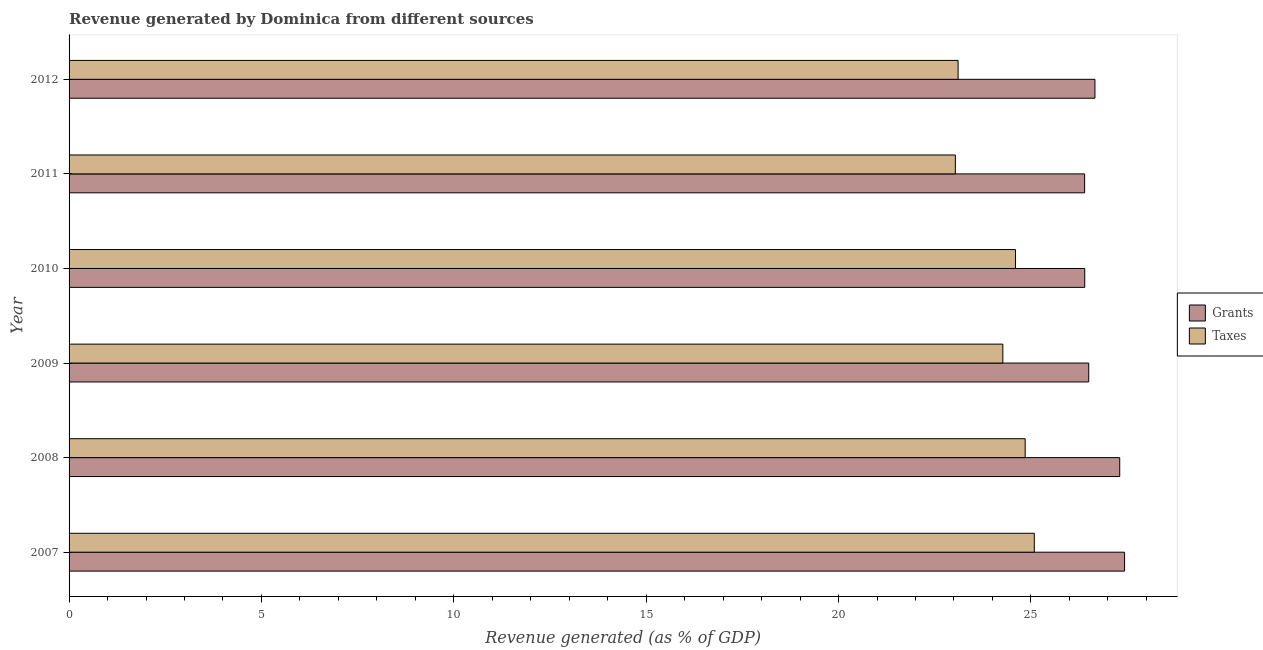How many different coloured bars are there?
Give a very brief answer. 2. How many groups of bars are there?
Make the answer very short. 6. Are the number of bars on each tick of the Y-axis equal?
Ensure brevity in your answer.  Yes. What is the revenue generated by taxes in 2007?
Provide a short and direct response. 25.09. Across all years, what is the maximum revenue generated by grants?
Your answer should be compact. 27.43. Across all years, what is the minimum revenue generated by taxes?
Ensure brevity in your answer.  23.04. In which year was the revenue generated by taxes maximum?
Ensure brevity in your answer.  2007. What is the total revenue generated by taxes in the graph?
Ensure brevity in your answer.  144.95. What is the difference between the revenue generated by taxes in 2007 and that in 2012?
Make the answer very short. 1.98. What is the difference between the revenue generated by grants in 2009 and the revenue generated by taxes in 2011?
Give a very brief answer. 3.47. What is the average revenue generated by taxes per year?
Keep it short and to the point. 24.16. In the year 2010, what is the difference between the revenue generated by grants and revenue generated by taxes?
Keep it short and to the point. 1.8. What is the ratio of the revenue generated by taxes in 2007 to that in 2009?
Offer a very short reply. 1.03. Is the revenue generated by grants in 2010 less than that in 2011?
Make the answer very short. No. What is the difference between the highest and the second highest revenue generated by grants?
Your answer should be compact. 0.13. What is the difference between the highest and the lowest revenue generated by taxes?
Make the answer very short. 2.05. Is the sum of the revenue generated by taxes in 2007 and 2011 greater than the maximum revenue generated by grants across all years?
Keep it short and to the point. Yes. What does the 2nd bar from the top in 2007 represents?
Offer a terse response. Grants. What does the 1st bar from the bottom in 2011 represents?
Ensure brevity in your answer.  Grants. How many bars are there?
Your answer should be compact. 12. What is the difference between two consecutive major ticks on the X-axis?
Make the answer very short. 5. Are the values on the major ticks of X-axis written in scientific E-notation?
Your answer should be very brief. No. How many legend labels are there?
Ensure brevity in your answer.  2. How are the legend labels stacked?
Keep it short and to the point. Vertical. What is the title of the graph?
Your answer should be very brief. Revenue generated by Dominica from different sources. Does "Nonresident" appear as one of the legend labels in the graph?
Offer a very short reply. No. What is the label or title of the X-axis?
Offer a very short reply. Revenue generated (as % of GDP). What is the label or title of the Y-axis?
Ensure brevity in your answer.  Year. What is the Revenue generated (as % of GDP) in Grants in 2007?
Your answer should be very brief. 27.43. What is the Revenue generated (as % of GDP) in Taxes in 2007?
Give a very brief answer. 25.09. What is the Revenue generated (as % of GDP) in Grants in 2008?
Offer a very short reply. 27.31. What is the Revenue generated (as % of GDP) of Taxes in 2008?
Keep it short and to the point. 24.85. What is the Revenue generated (as % of GDP) in Grants in 2009?
Your answer should be very brief. 26.5. What is the Revenue generated (as % of GDP) of Taxes in 2009?
Make the answer very short. 24.27. What is the Revenue generated (as % of GDP) of Grants in 2010?
Offer a terse response. 26.4. What is the Revenue generated (as % of GDP) in Taxes in 2010?
Your answer should be compact. 24.6. What is the Revenue generated (as % of GDP) in Grants in 2011?
Provide a short and direct response. 26.4. What is the Revenue generated (as % of GDP) in Taxes in 2011?
Make the answer very short. 23.04. What is the Revenue generated (as % of GDP) in Grants in 2012?
Your response must be concise. 26.66. What is the Revenue generated (as % of GDP) in Taxes in 2012?
Your answer should be compact. 23.11. Across all years, what is the maximum Revenue generated (as % of GDP) of Grants?
Your answer should be very brief. 27.43. Across all years, what is the maximum Revenue generated (as % of GDP) of Taxes?
Make the answer very short. 25.09. Across all years, what is the minimum Revenue generated (as % of GDP) of Grants?
Your answer should be compact. 26.4. Across all years, what is the minimum Revenue generated (as % of GDP) in Taxes?
Provide a succinct answer. 23.04. What is the total Revenue generated (as % of GDP) in Grants in the graph?
Ensure brevity in your answer.  160.7. What is the total Revenue generated (as % of GDP) in Taxes in the graph?
Offer a very short reply. 144.95. What is the difference between the Revenue generated (as % of GDP) in Grants in 2007 and that in 2008?
Make the answer very short. 0.13. What is the difference between the Revenue generated (as % of GDP) of Taxes in 2007 and that in 2008?
Make the answer very short. 0.24. What is the difference between the Revenue generated (as % of GDP) in Grants in 2007 and that in 2009?
Keep it short and to the point. 0.93. What is the difference between the Revenue generated (as % of GDP) in Taxes in 2007 and that in 2009?
Give a very brief answer. 0.82. What is the difference between the Revenue generated (as % of GDP) in Grants in 2007 and that in 2010?
Keep it short and to the point. 1.03. What is the difference between the Revenue generated (as % of GDP) in Taxes in 2007 and that in 2010?
Your answer should be very brief. 0.49. What is the difference between the Revenue generated (as % of GDP) in Grants in 2007 and that in 2011?
Ensure brevity in your answer.  1.04. What is the difference between the Revenue generated (as % of GDP) of Taxes in 2007 and that in 2011?
Provide a short and direct response. 2.05. What is the difference between the Revenue generated (as % of GDP) in Grants in 2007 and that in 2012?
Offer a very short reply. 0.77. What is the difference between the Revenue generated (as % of GDP) of Taxes in 2007 and that in 2012?
Offer a terse response. 1.98. What is the difference between the Revenue generated (as % of GDP) in Grants in 2008 and that in 2009?
Provide a succinct answer. 0.81. What is the difference between the Revenue generated (as % of GDP) in Taxes in 2008 and that in 2009?
Give a very brief answer. 0.58. What is the difference between the Revenue generated (as % of GDP) of Grants in 2008 and that in 2010?
Your answer should be compact. 0.91. What is the difference between the Revenue generated (as % of GDP) of Taxes in 2008 and that in 2010?
Provide a succinct answer. 0.25. What is the difference between the Revenue generated (as % of GDP) in Grants in 2008 and that in 2011?
Keep it short and to the point. 0.91. What is the difference between the Revenue generated (as % of GDP) in Taxes in 2008 and that in 2011?
Provide a short and direct response. 1.81. What is the difference between the Revenue generated (as % of GDP) in Grants in 2008 and that in 2012?
Offer a very short reply. 0.64. What is the difference between the Revenue generated (as % of GDP) of Taxes in 2008 and that in 2012?
Your answer should be compact. 1.74. What is the difference between the Revenue generated (as % of GDP) of Grants in 2009 and that in 2010?
Your response must be concise. 0.1. What is the difference between the Revenue generated (as % of GDP) in Taxes in 2009 and that in 2010?
Keep it short and to the point. -0.33. What is the difference between the Revenue generated (as % of GDP) of Grants in 2009 and that in 2011?
Provide a short and direct response. 0.11. What is the difference between the Revenue generated (as % of GDP) in Taxes in 2009 and that in 2011?
Provide a succinct answer. 1.23. What is the difference between the Revenue generated (as % of GDP) in Grants in 2009 and that in 2012?
Offer a terse response. -0.16. What is the difference between the Revenue generated (as % of GDP) of Taxes in 2009 and that in 2012?
Your response must be concise. 1.16. What is the difference between the Revenue generated (as % of GDP) in Grants in 2010 and that in 2011?
Keep it short and to the point. 0. What is the difference between the Revenue generated (as % of GDP) in Taxes in 2010 and that in 2011?
Your answer should be compact. 1.56. What is the difference between the Revenue generated (as % of GDP) in Grants in 2010 and that in 2012?
Provide a short and direct response. -0.27. What is the difference between the Revenue generated (as % of GDP) of Taxes in 2010 and that in 2012?
Your answer should be compact. 1.49. What is the difference between the Revenue generated (as % of GDP) of Grants in 2011 and that in 2012?
Provide a short and direct response. -0.27. What is the difference between the Revenue generated (as % of GDP) in Taxes in 2011 and that in 2012?
Your answer should be compact. -0.07. What is the difference between the Revenue generated (as % of GDP) of Grants in 2007 and the Revenue generated (as % of GDP) of Taxes in 2008?
Keep it short and to the point. 2.58. What is the difference between the Revenue generated (as % of GDP) of Grants in 2007 and the Revenue generated (as % of GDP) of Taxes in 2009?
Keep it short and to the point. 3.16. What is the difference between the Revenue generated (as % of GDP) in Grants in 2007 and the Revenue generated (as % of GDP) in Taxes in 2010?
Your answer should be compact. 2.84. What is the difference between the Revenue generated (as % of GDP) in Grants in 2007 and the Revenue generated (as % of GDP) in Taxes in 2011?
Keep it short and to the point. 4.4. What is the difference between the Revenue generated (as % of GDP) in Grants in 2007 and the Revenue generated (as % of GDP) in Taxes in 2012?
Provide a succinct answer. 4.33. What is the difference between the Revenue generated (as % of GDP) of Grants in 2008 and the Revenue generated (as % of GDP) of Taxes in 2009?
Your answer should be very brief. 3.04. What is the difference between the Revenue generated (as % of GDP) in Grants in 2008 and the Revenue generated (as % of GDP) in Taxes in 2010?
Offer a very short reply. 2.71. What is the difference between the Revenue generated (as % of GDP) in Grants in 2008 and the Revenue generated (as % of GDP) in Taxes in 2011?
Offer a very short reply. 4.27. What is the difference between the Revenue generated (as % of GDP) of Grants in 2008 and the Revenue generated (as % of GDP) of Taxes in 2012?
Make the answer very short. 4.2. What is the difference between the Revenue generated (as % of GDP) in Grants in 2009 and the Revenue generated (as % of GDP) in Taxes in 2010?
Your answer should be very brief. 1.9. What is the difference between the Revenue generated (as % of GDP) in Grants in 2009 and the Revenue generated (as % of GDP) in Taxes in 2011?
Offer a terse response. 3.47. What is the difference between the Revenue generated (as % of GDP) in Grants in 2009 and the Revenue generated (as % of GDP) in Taxes in 2012?
Your answer should be compact. 3.4. What is the difference between the Revenue generated (as % of GDP) of Grants in 2010 and the Revenue generated (as % of GDP) of Taxes in 2011?
Offer a very short reply. 3.36. What is the difference between the Revenue generated (as % of GDP) of Grants in 2010 and the Revenue generated (as % of GDP) of Taxes in 2012?
Ensure brevity in your answer.  3.29. What is the difference between the Revenue generated (as % of GDP) of Grants in 2011 and the Revenue generated (as % of GDP) of Taxes in 2012?
Your answer should be compact. 3.29. What is the average Revenue generated (as % of GDP) in Grants per year?
Make the answer very short. 26.78. What is the average Revenue generated (as % of GDP) of Taxes per year?
Give a very brief answer. 24.16. In the year 2007, what is the difference between the Revenue generated (as % of GDP) in Grants and Revenue generated (as % of GDP) in Taxes?
Ensure brevity in your answer.  2.35. In the year 2008, what is the difference between the Revenue generated (as % of GDP) of Grants and Revenue generated (as % of GDP) of Taxes?
Your response must be concise. 2.46. In the year 2009, what is the difference between the Revenue generated (as % of GDP) in Grants and Revenue generated (as % of GDP) in Taxes?
Provide a short and direct response. 2.23. In the year 2010, what is the difference between the Revenue generated (as % of GDP) of Grants and Revenue generated (as % of GDP) of Taxes?
Your response must be concise. 1.8. In the year 2011, what is the difference between the Revenue generated (as % of GDP) of Grants and Revenue generated (as % of GDP) of Taxes?
Your answer should be very brief. 3.36. In the year 2012, what is the difference between the Revenue generated (as % of GDP) in Grants and Revenue generated (as % of GDP) in Taxes?
Keep it short and to the point. 3.56. What is the ratio of the Revenue generated (as % of GDP) of Taxes in 2007 to that in 2008?
Offer a very short reply. 1.01. What is the ratio of the Revenue generated (as % of GDP) of Grants in 2007 to that in 2009?
Offer a very short reply. 1.04. What is the ratio of the Revenue generated (as % of GDP) in Taxes in 2007 to that in 2009?
Provide a short and direct response. 1.03. What is the ratio of the Revenue generated (as % of GDP) in Grants in 2007 to that in 2010?
Ensure brevity in your answer.  1.04. What is the ratio of the Revenue generated (as % of GDP) in Taxes in 2007 to that in 2010?
Your answer should be very brief. 1.02. What is the ratio of the Revenue generated (as % of GDP) in Grants in 2007 to that in 2011?
Give a very brief answer. 1.04. What is the ratio of the Revenue generated (as % of GDP) in Taxes in 2007 to that in 2011?
Give a very brief answer. 1.09. What is the ratio of the Revenue generated (as % of GDP) of Grants in 2007 to that in 2012?
Ensure brevity in your answer.  1.03. What is the ratio of the Revenue generated (as % of GDP) of Taxes in 2007 to that in 2012?
Offer a terse response. 1.09. What is the ratio of the Revenue generated (as % of GDP) of Grants in 2008 to that in 2009?
Your answer should be very brief. 1.03. What is the ratio of the Revenue generated (as % of GDP) in Taxes in 2008 to that in 2009?
Your answer should be compact. 1.02. What is the ratio of the Revenue generated (as % of GDP) in Grants in 2008 to that in 2010?
Your response must be concise. 1.03. What is the ratio of the Revenue generated (as % of GDP) in Taxes in 2008 to that in 2010?
Make the answer very short. 1.01. What is the ratio of the Revenue generated (as % of GDP) of Grants in 2008 to that in 2011?
Your answer should be compact. 1.03. What is the ratio of the Revenue generated (as % of GDP) in Taxes in 2008 to that in 2011?
Provide a short and direct response. 1.08. What is the ratio of the Revenue generated (as % of GDP) in Grants in 2008 to that in 2012?
Make the answer very short. 1.02. What is the ratio of the Revenue generated (as % of GDP) of Taxes in 2008 to that in 2012?
Provide a short and direct response. 1.08. What is the ratio of the Revenue generated (as % of GDP) in Taxes in 2009 to that in 2010?
Make the answer very short. 0.99. What is the ratio of the Revenue generated (as % of GDP) of Grants in 2009 to that in 2011?
Provide a succinct answer. 1. What is the ratio of the Revenue generated (as % of GDP) in Taxes in 2009 to that in 2011?
Make the answer very short. 1.05. What is the ratio of the Revenue generated (as % of GDP) in Grants in 2009 to that in 2012?
Your response must be concise. 0.99. What is the ratio of the Revenue generated (as % of GDP) in Taxes in 2009 to that in 2012?
Your answer should be very brief. 1.05. What is the ratio of the Revenue generated (as % of GDP) of Grants in 2010 to that in 2011?
Ensure brevity in your answer.  1. What is the ratio of the Revenue generated (as % of GDP) in Taxes in 2010 to that in 2011?
Your answer should be compact. 1.07. What is the ratio of the Revenue generated (as % of GDP) in Taxes in 2010 to that in 2012?
Provide a short and direct response. 1.06. What is the ratio of the Revenue generated (as % of GDP) in Grants in 2011 to that in 2012?
Your answer should be very brief. 0.99. What is the difference between the highest and the second highest Revenue generated (as % of GDP) of Grants?
Keep it short and to the point. 0.13. What is the difference between the highest and the second highest Revenue generated (as % of GDP) in Taxes?
Provide a succinct answer. 0.24. What is the difference between the highest and the lowest Revenue generated (as % of GDP) of Grants?
Ensure brevity in your answer.  1.04. What is the difference between the highest and the lowest Revenue generated (as % of GDP) of Taxes?
Your answer should be very brief. 2.05. 